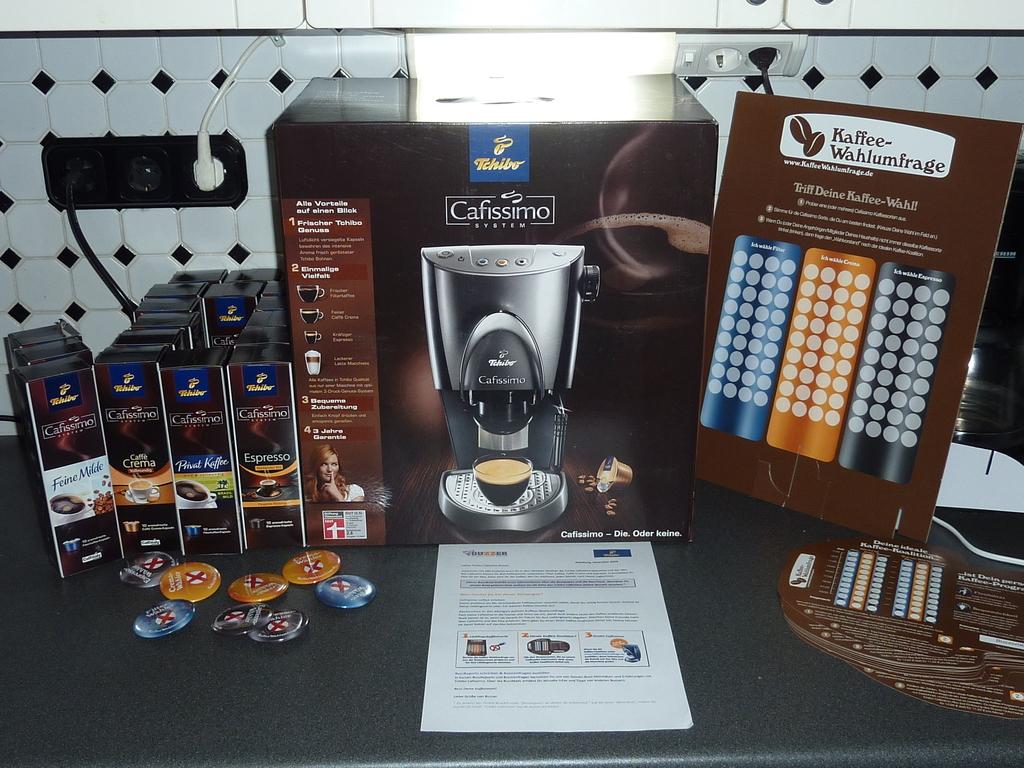What is in the big brown box?
Ensure brevity in your answer.  Cafissimo system. 